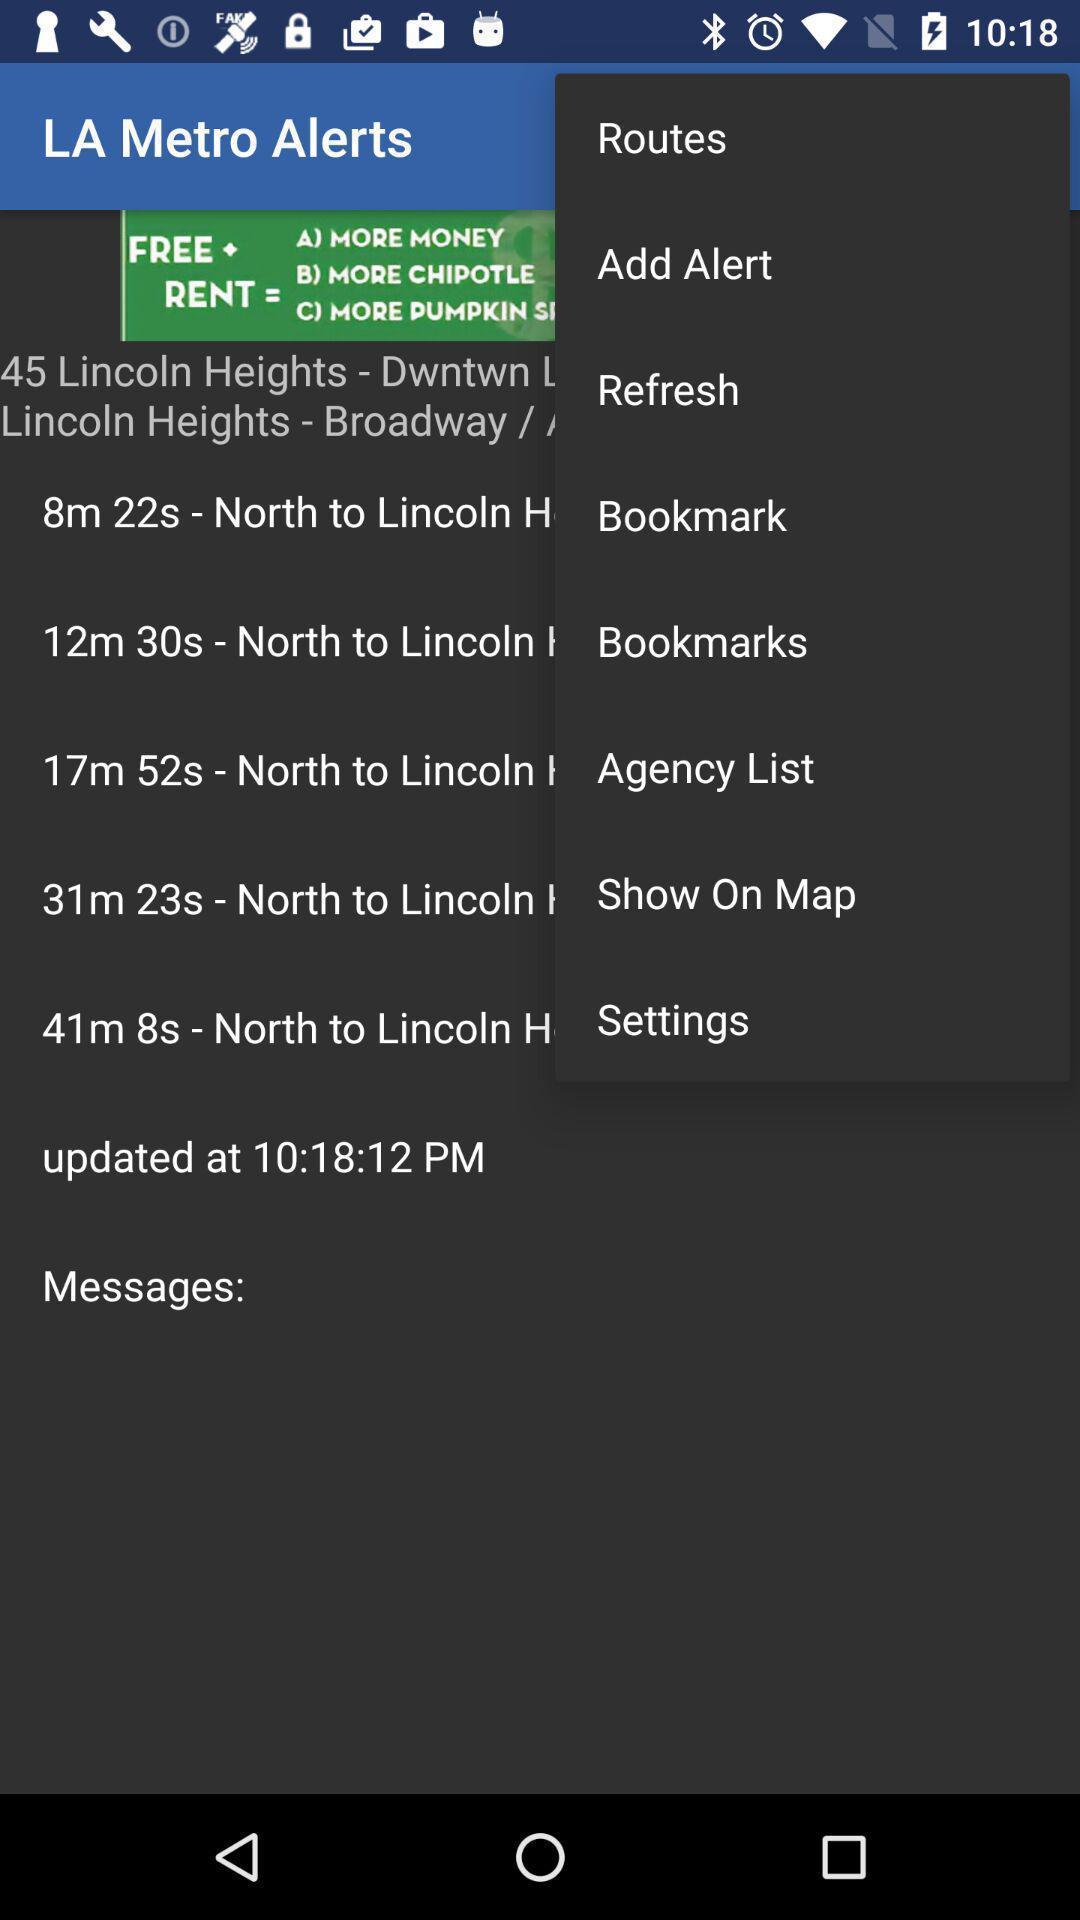Provide a textual representation of this image. Screen shows multiple options. 